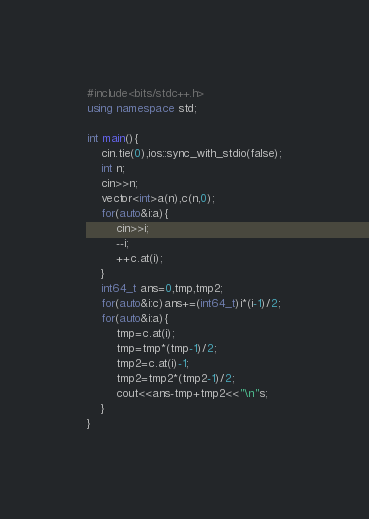<code> <loc_0><loc_0><loc_500><loc_500><_C++_>#include<bits/stdc++.h>
using namespace std;

int main(){
	cin.tie(0),ios::sync_with_stdio(false);
	int n;
	cin>>n;
	vector<int>a(n),c(n,0);
	for(auto&i:a){
		cin>>i;
		--i;
		++c.at(i);
	}
	int64_t ans=0,tmp,tmp2;
	for(auto&i:c)ans+=(int64_t)i*(i-1)/2;
	for(auto&i:a){
		tmp=c.at(i);
		tmp=tmp*(tmp-1)/2;
		tmp2=c.at(i)-1;
		tmp2=tmp2*(tmp2-1)/2;
		cout<<ans-tmp+tmp2<<"\n"s;
	}
}</code> 